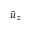<formula> <loc_0><loc_0><loc_500><loc_500>\tilde { u } _ { z }</formula> 